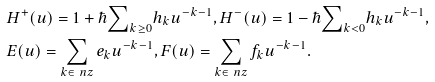Convert formula to latex. <formula><loc_0><loc_0><loc_500><loc_500>& H ^ { + } ( u ) = 1 + \hbar { \sum } _ { k \geq 0 } h _ { k } u ^ { - k - 1 } , H ^ { - } ( u ) = 1 - \hbar { \sum } _ { k < 0 } h _ { k } u ^ { - k - 1 } , \\ & E ( u ) = \sum _ { k \in \ n z } e _ { k } u ^ { - k - 1 } , F ( u ) = \sum _ { k \in \ n z } f _ { k } u ^ { - k - 1 } .</formula> 